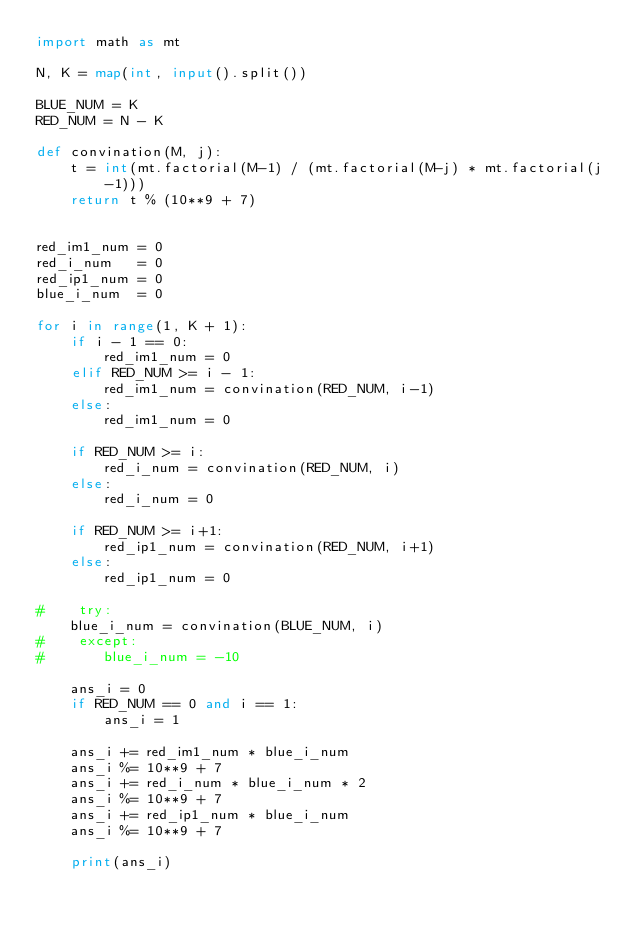Convert code to text. <code><loc_0><loc_0><loc_500><loc_500><_Python_>import math as mt

N, K = map(int, input().split())

BLUE_NUM = K
RED_NUM = N - K

def convination(M, j):
    t = int(mt.factorial(M-1) / (mt.factorial(M-j) * mt.factorial(j-1)))
    return t % (10**9 + 7)


red_im1_num = 0
red_i_num   = 0
red_ip1_num = 0
blue_i_num  = 0

for i in range(1, K + 1):
    if i - 1 == 0:
        red_im1_num = 0
    elif RED_NUM >= i - 1:
        red_im1_num = convination(RED_NUM, i-1)
    else:
        red_im1_num = 0

    if RED_NUM >= i:
        red_i_num = convination(RED_NUM, i)
    else:
        red_i_num = 0

    if RED_NUM >= i+1:
        red_ip1_num = convination(RED_NUM, i+1)
    else:
        red_ip1_num = 0

#    try:
    blue_i_num = convination(BLUE_NUM, i)
#    except:
#       blue_i_num = -10

    ans_i = 0
    if RED_NUM == 0 and i == 1:
        ans_i = 1

    ans_i += red_im1_num * blue_i_num
    ans_i %= 10**9 + 7
    ans_i += red_i_num * blue_i_num * 2
    ans_i %= 10**9 + 7
    ans_i += red_ip1_num * blue_i_num
    ans_i %= 10**9 + 7

    print(ans_i)
</code> 